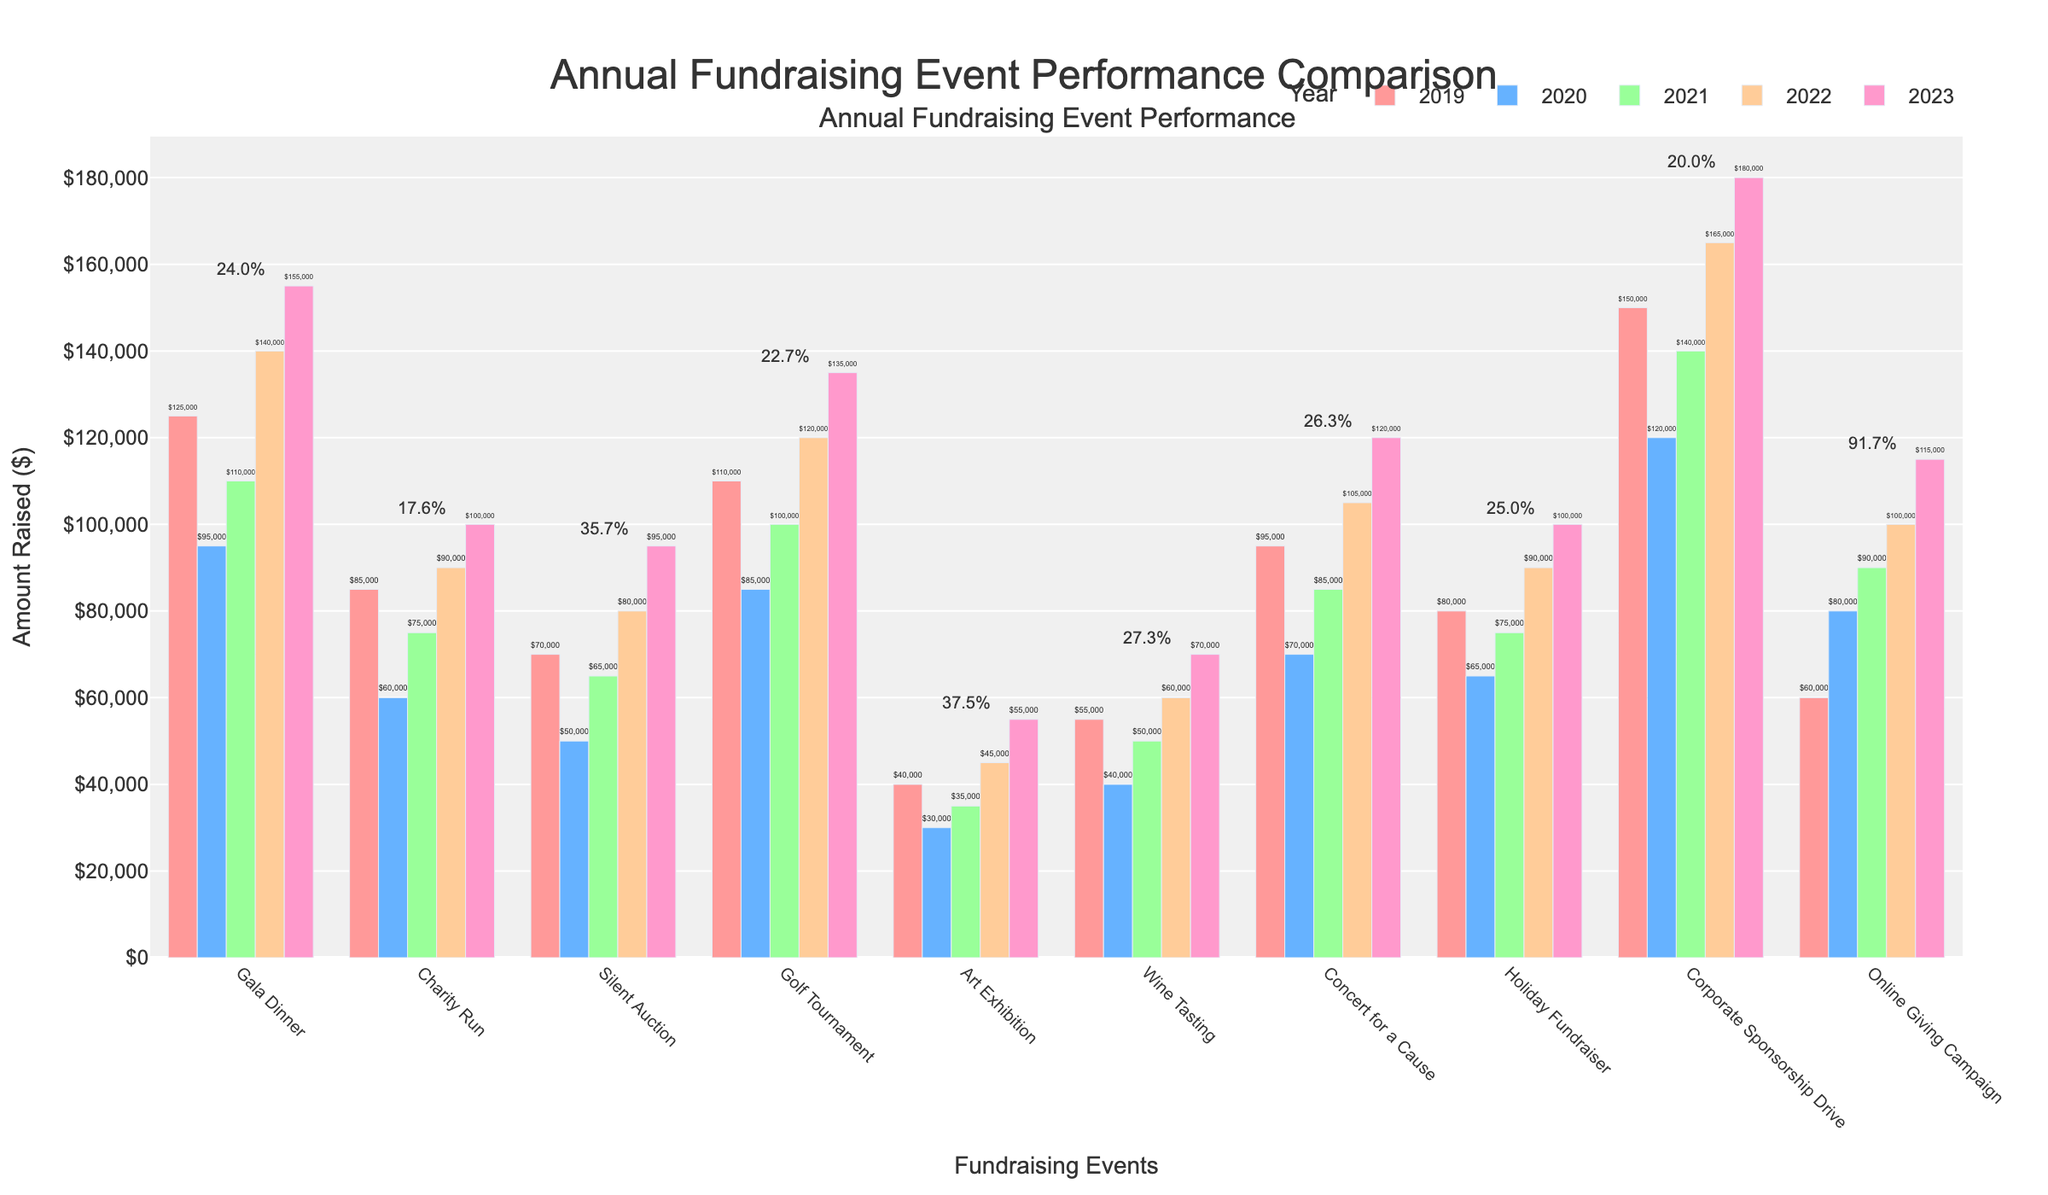What event had the highest amount raised in 2023? By looking at the bar heights for 2023, identify which event has the tallest bar. The Corporate Sponsorship Drive appears to have the tallest bar in 2023, indicating it raised the most funds that year.
Answer: Corporate Sponsorship Drive Which event showed the largest percentage increase in funds raised from 2019 to 2023? Check the annotations above each event for the percentage change and identify the highest value. The Art Exhibition has the highest annotated percentage increase, which is 37.5%.
Answer: Art Exhibition How much more did the Gala Dinner raise in 2023 compared to 2020? Compare the bar heights for the Gala Dinner in 2023 and 2020. The 2023 bar is $155,000 and the 2020 bar is $95,000. Subtract the 2020 value from the 2023 value: $155,000 - $95,000 = $60,000.
Answer: $60,000 Which two events raised the same amount in 2023? Look for bars that reach the same height in 2023. Both the Charity Run and the Holiday Fundraiser raised $100,000 in 2023.
Answer: Charity Run and Holiday Fundraiser Comparing the Silent Auction and Concert for a Cause, which had a higher amount raised in 2022 and by how much? For 2022, the Silent Auction raised $80,000 and Concert for a Cause raised $105,000. Subtract the Silent Auction amount from the Concert for a Cause amount: $105,000 - $80,000 = $25,000.
Answer: Concert for a Cause, $25,000 What is the total amount raised by the Wine Tasting event over the last five years (2019-2023)? Add up the amounts raised by the Wine Tasting event each year: $55,000 (2019) + $40,000 (2020) + $50,000 (2021) + $60,000 (2022) + $70,000 (2023) = $275,000.
Answer: $275,000 Which year had the overall lowest total fundraising amount across all events and what was that amount? Sum up the funds raised for each year across all events. Compare these sums to identify the lowest one. The sums are: 2019 - $860,000; 2020 - $620,000; 2021 - $745,000; 2022 - $950,000; 2023 - $1,120,000. The lowest total is in 2020 with $620,000.
Answer: 2020, $620,000 Which event had the most significant drop in funds raised from 2019 to 2020, and how much was this drop? Compare the 2019 and 2020 bars for each event and calculate the differences. The Gala Dinner had a drop from $125,000 in 2019 to $95,000 in 2020, which is a $30,000 decrease.
Answer: Gala Dinner, $30,000 